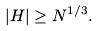<formula> <loc_0><loc_0><loc_500><loc_500>| H | \geq N ^ { 1 / 3 } .</formula> 